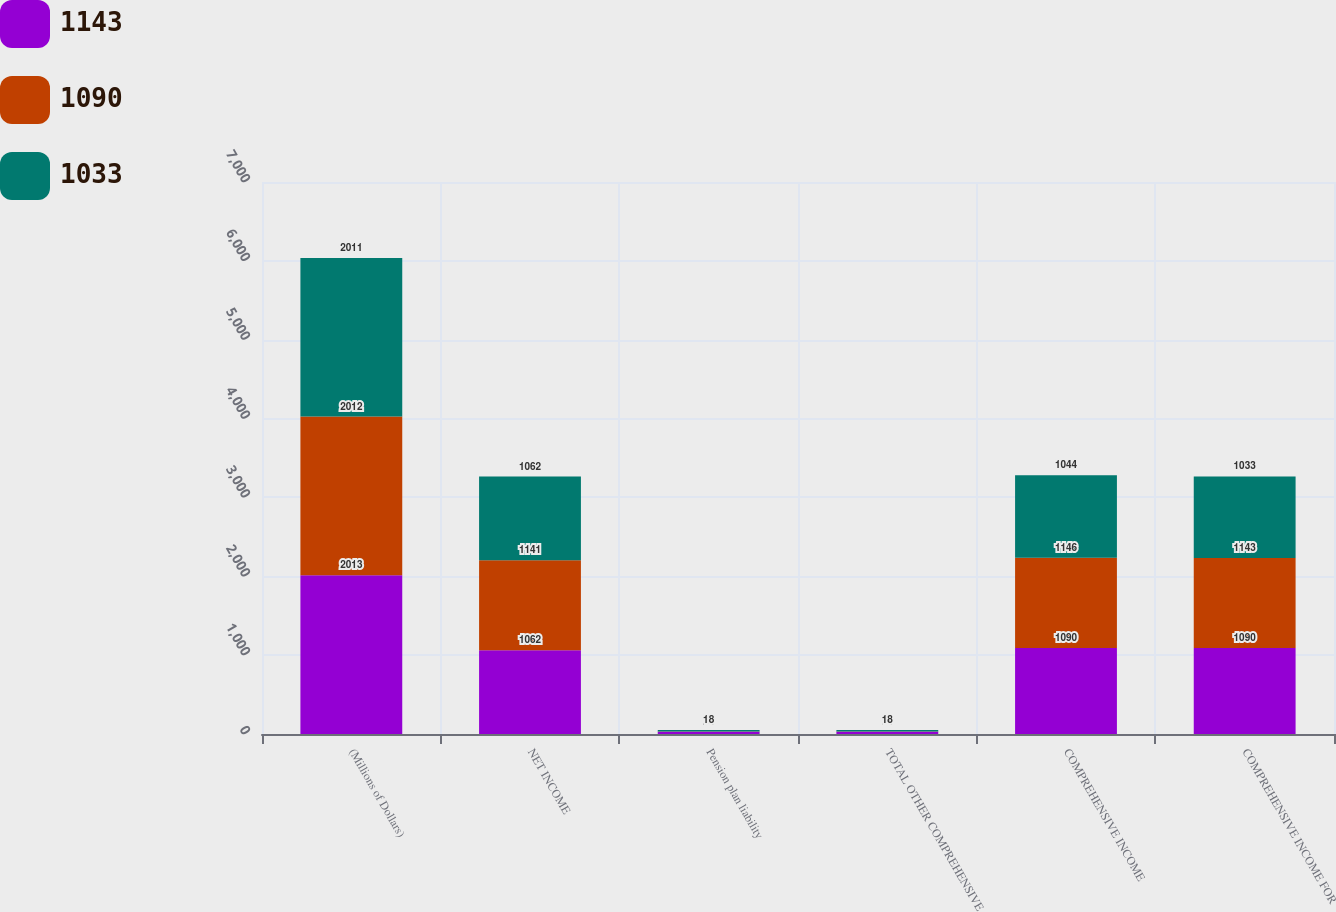<chart> <loc_0><loc_0><loc_500><loc_500><stacked_bar_chart><ecel><fcel>(Millions of Dollars)<fcel>NET INCOME<fcel>Pension plan liability<fcel>TOTAL OTHER COMPREHENSIVE<fcel>COMPREHENSIVE INCOME<fcel>COMPREHENSIVE INCOME FOR<nl><fcel>1143<fcel>2013<fcel>1062<fcel>28<fcel>28<fcel>1090<fcel>1090<nl><fcel>1090<fcel>2012<fcel>1141<fcel>5<fcel>5<fcel>1146<fcel>1143<nl><fcel>1033<fcel>2011<fcel>1062<fcel>18<fcel>18<fcel>1044<fcel>1033<nl></chart> 